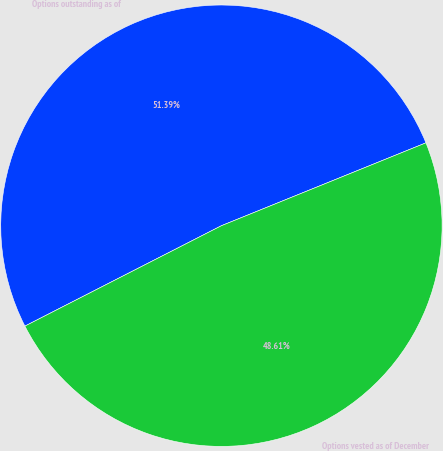Convert chart to OTSL. <chart><loc_0><loc_0><loc_500><loc_500><pie_chart><fcel>Options outstanding as of<fcel>Options vested as of December<nl><fcel>51.39%<fcel>48.61%<nl></chart> 